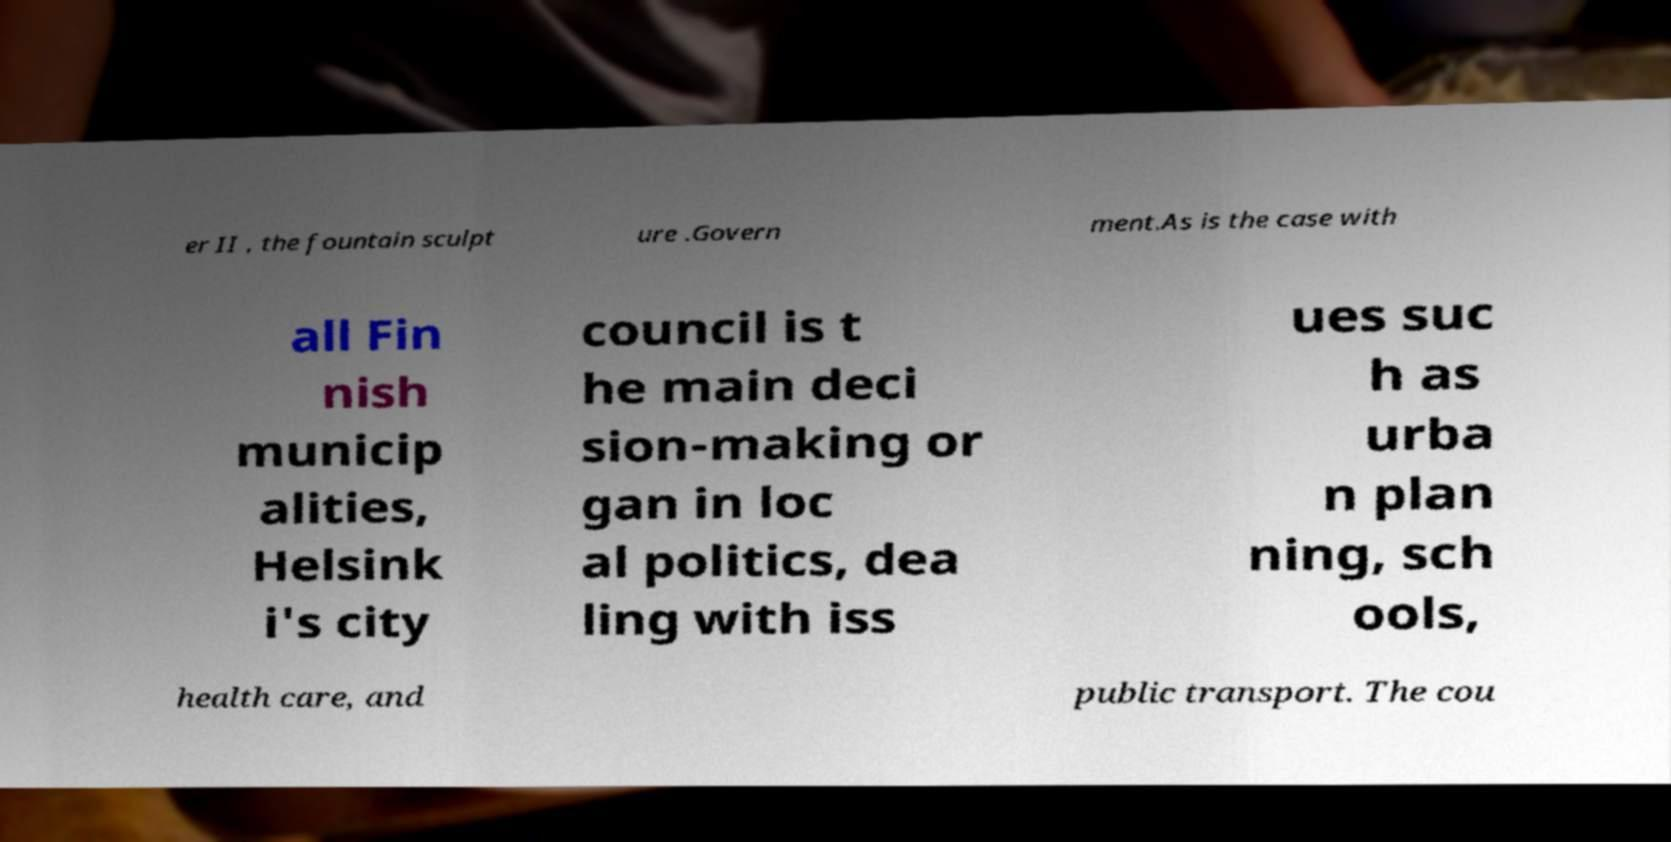I need the written content from this picture converted into text. Can you do that? er II , the fountain sculpt ure .Govern ment.As is the case with all Fin nish municip alities, Helsink i's city council is t he main deci sion-making or gan in loc al politics, dea ling with iss ues suc h as urba n plan ning, sch ools, health care, and public transport. The cou 